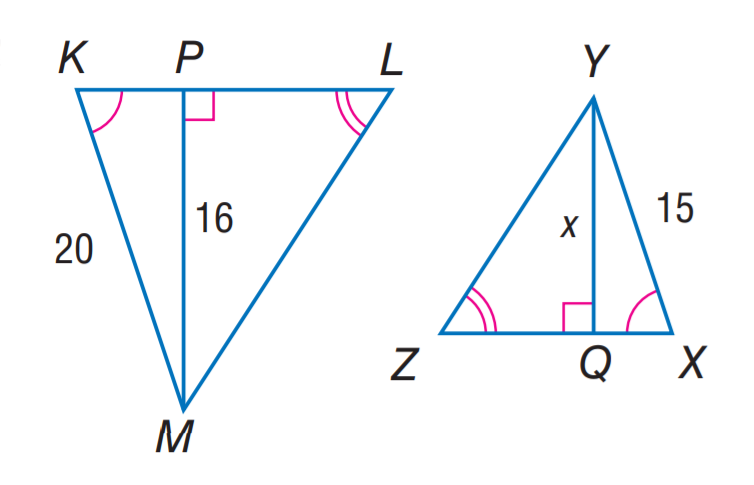Question: Find x.
Choices:
A. 8
B. 12
C. 15
D. 16
Answer with the letter. Answer: B 